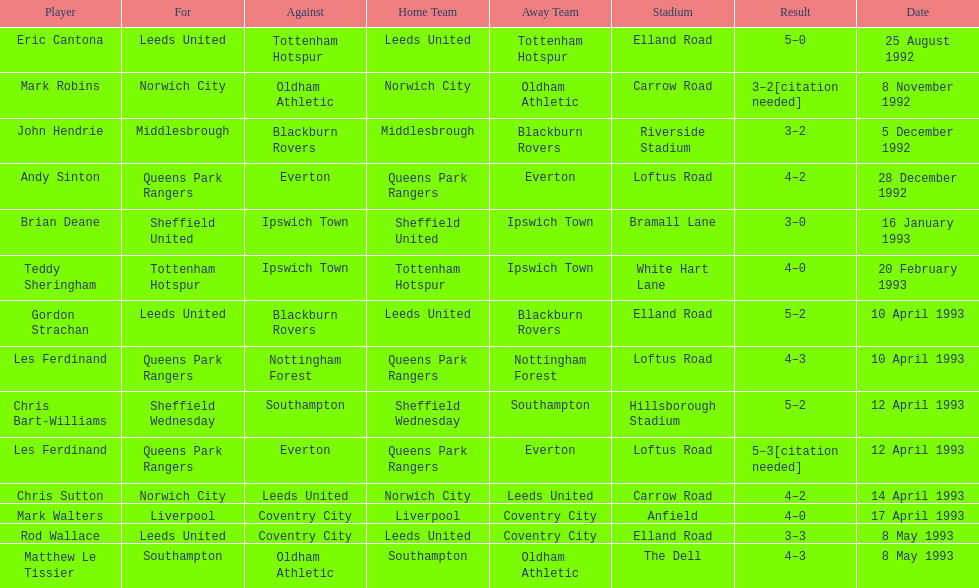Name the only player from france. Eric Cantona. 